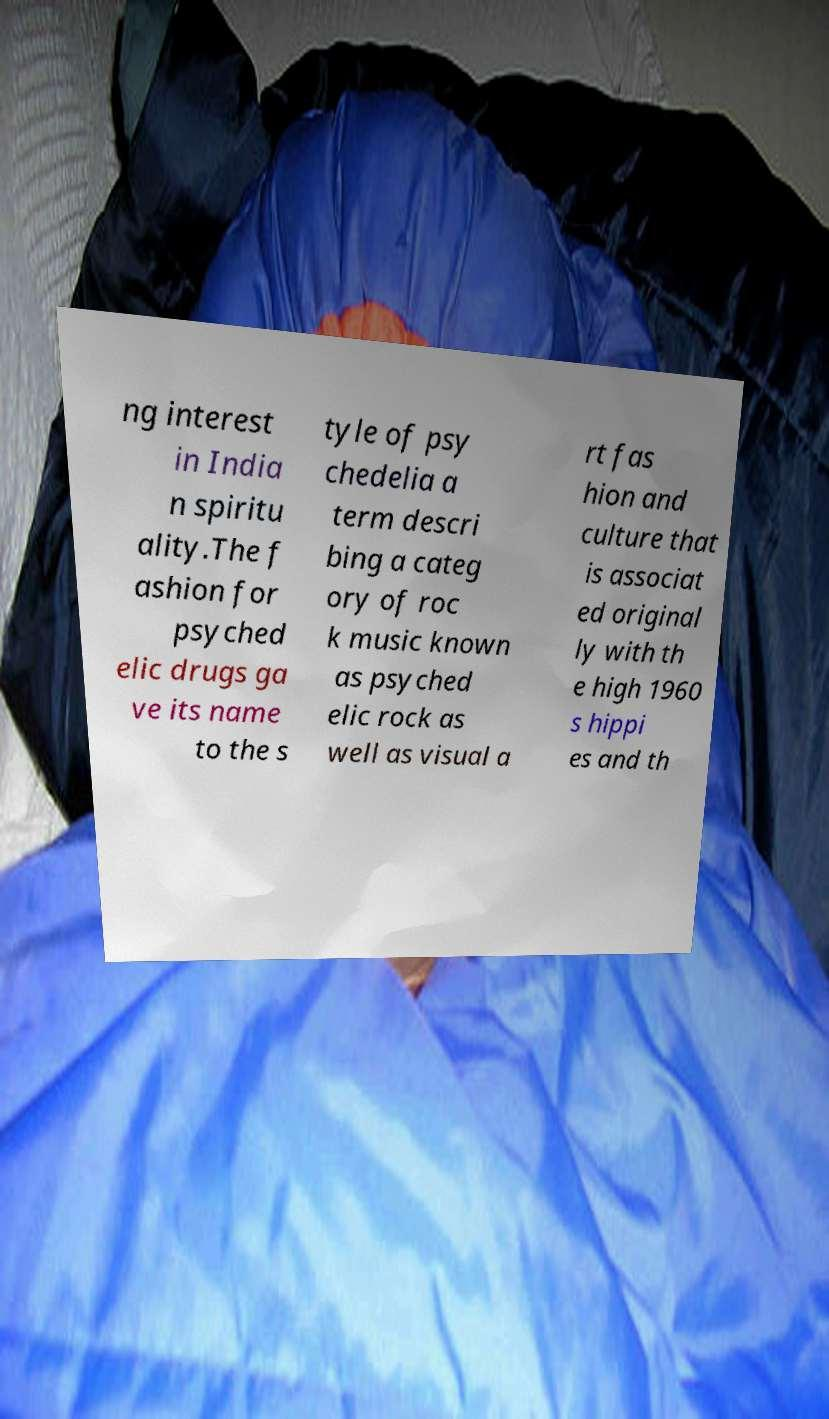What messages or text are displayed in this image? I need them in a readable, typed format. ng interest in India n spiritu ality.The f ashion for psyched elic drugs ga ve its name to the s tyle of psy chedelia a term descri bing a categ ory of roc k music known as psyched elic rock as well as visual a rt fas hion and culture that is associat ed original ly with th e high 1960 s hippi es and th 